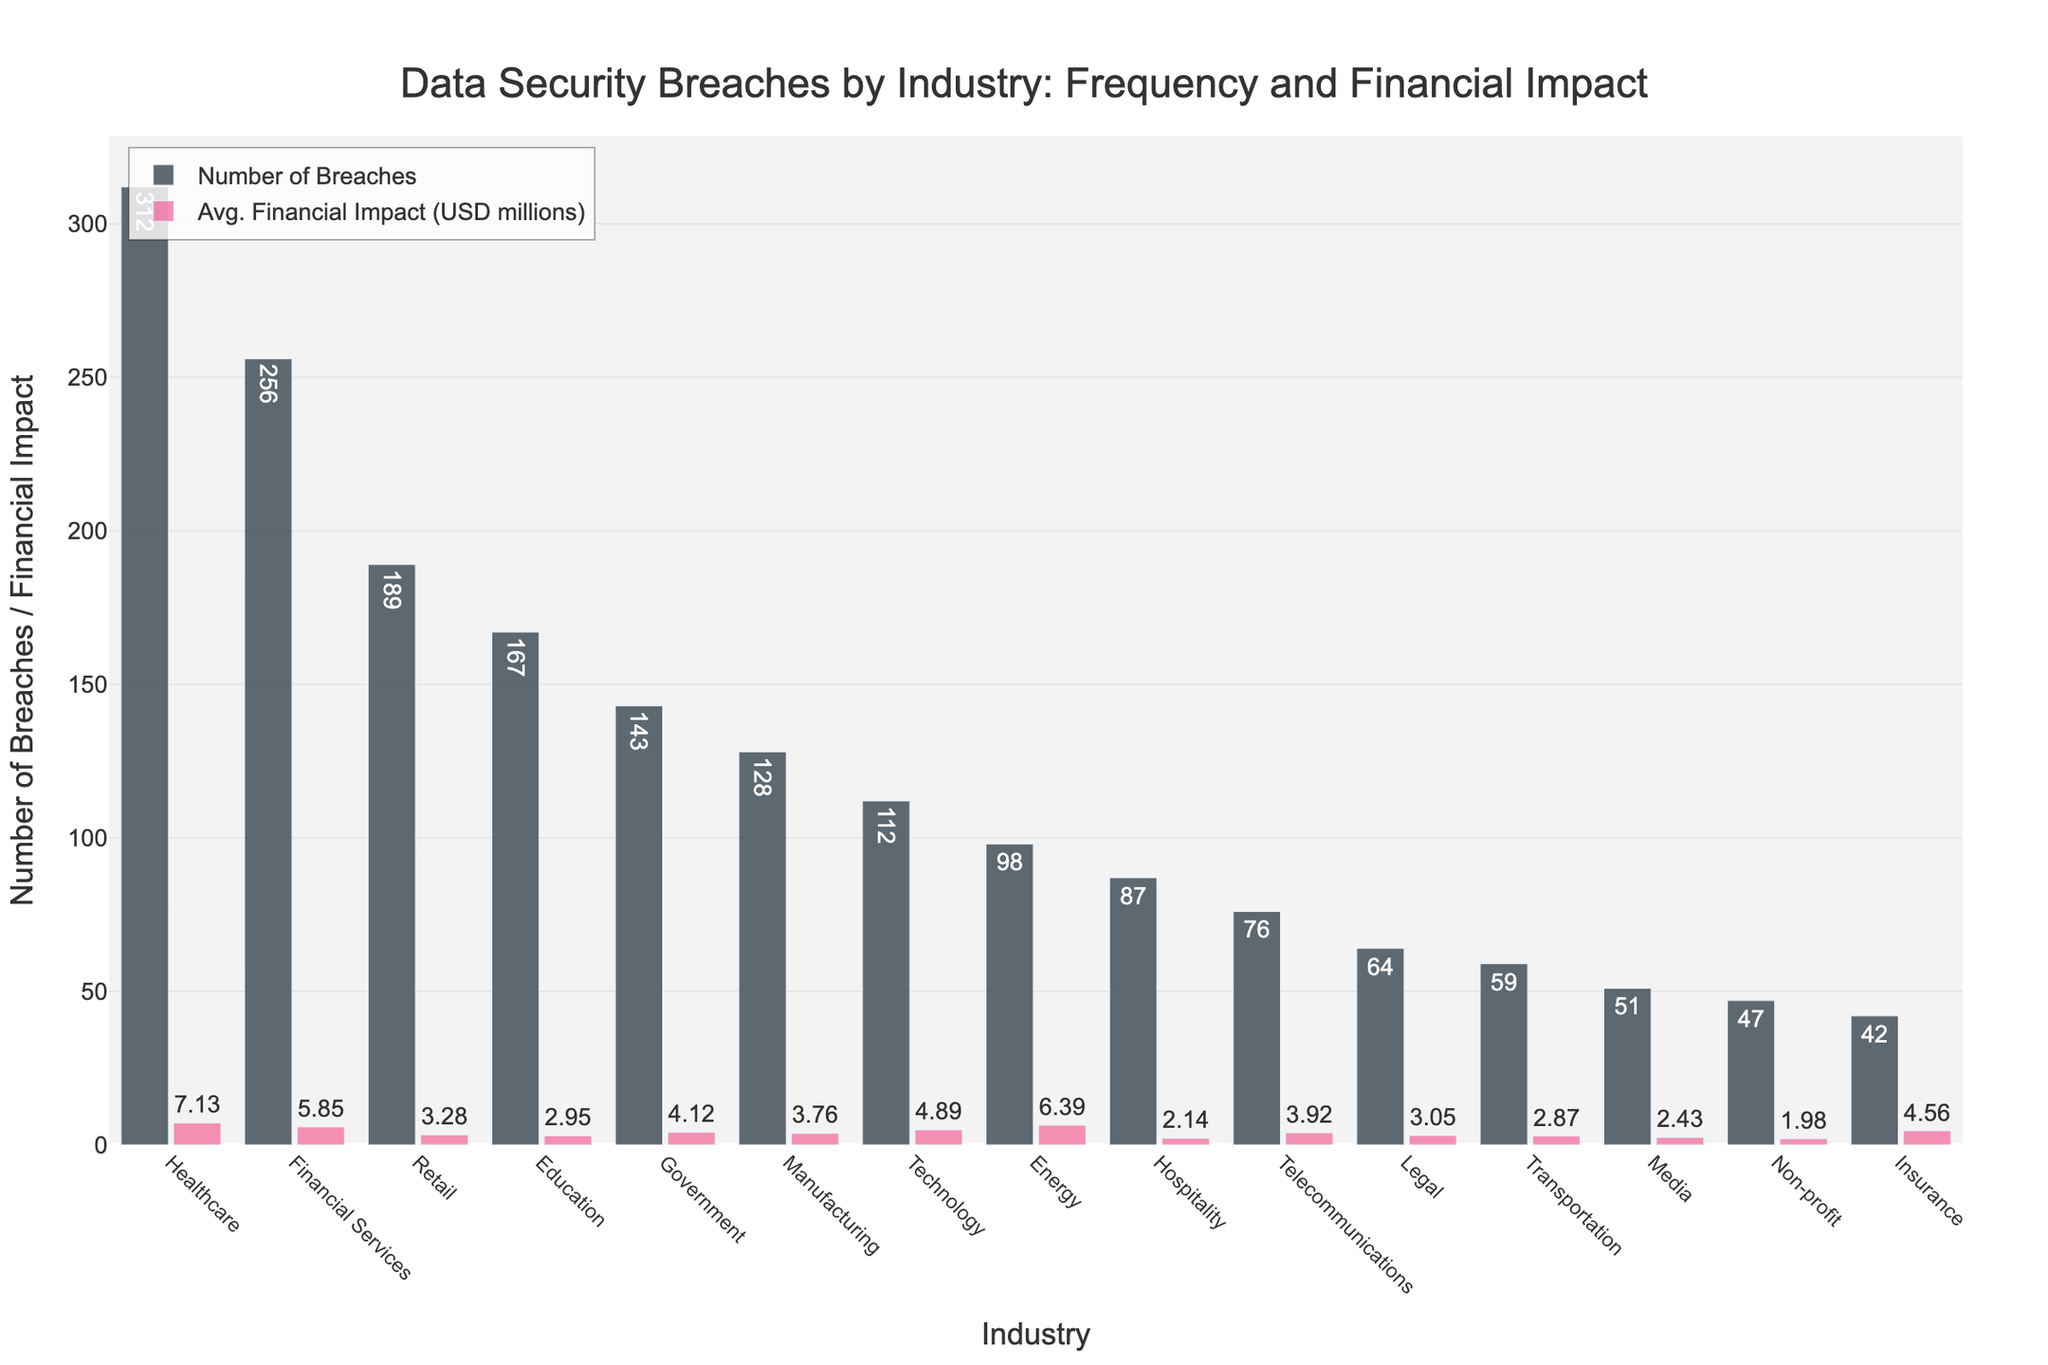Which industry has the highest number of data breaches? Look at the bar representing the number of breaches for each industry. The tallest bar indicates the highest number. Healthcare has the highest bar for breaches.
Answer: Healthcare What is the average financial impact of data breaches in the Energy industry? Refer to the bar labeled "Avg. Financial Impact (USD millions)" for the Energy industry. The bar’s text annotation will display the average financial impact.
Answer: 6.39 How does the financial impact of breaches in the Financial Services industry compare to the Retail industry? Compare the heights of the bars representing the average financial impact for Financial Services and Retail. Financial Services has a higher average financial impact bar.
Answer: Higher Which two industries have the closest number of data breaches? Find pairs of bars that are nearly the same height in the "Number of Breaches" category. Government and Manufacturing have similarly tall bars.
Answer: Government and Manufacturing What is the total number of breaches in the Healthcare and Retail industries combined? Sum the number of breaches for Healthcare and Retail. Healthcare has 312 breaches, and Retail has 189. 312 + 189 = 501
Answer: 501 Which industry has the lowest average financial impact of data breaches? Identify the shortest bar in the "Avg. Financial Impact (USD millions)" category. The bar for Non-profit is the shortest.
Answer: Non-profit Is the average financial impact of data breaches in the Education sector higher or lower than Telecommunications? Compare the heights of the respective bars. Education has a lower average financial impact compared to Telecommunications.
Answer: Lower What is the absolute difference in the number of breaches between the Technology and Hospitality industries? Subtract the number of breaches in Hospitality from Technology: 112 - 87 = 25
Answer: 25 Which industry has a higher average financial impact: Transportation or Legal? Compare the bar heights for the average financial impact of Transportation and Legal. Legal has a slightly higher bar.
Answer: Legal Across all industries, what is the sum of the average financial impacts of the Government and Technology sectors? Add the average financial impacts of Government (4.12) and Technology (4.89). 4.12 + 4.89 = 9.01
Answer: 9.01 